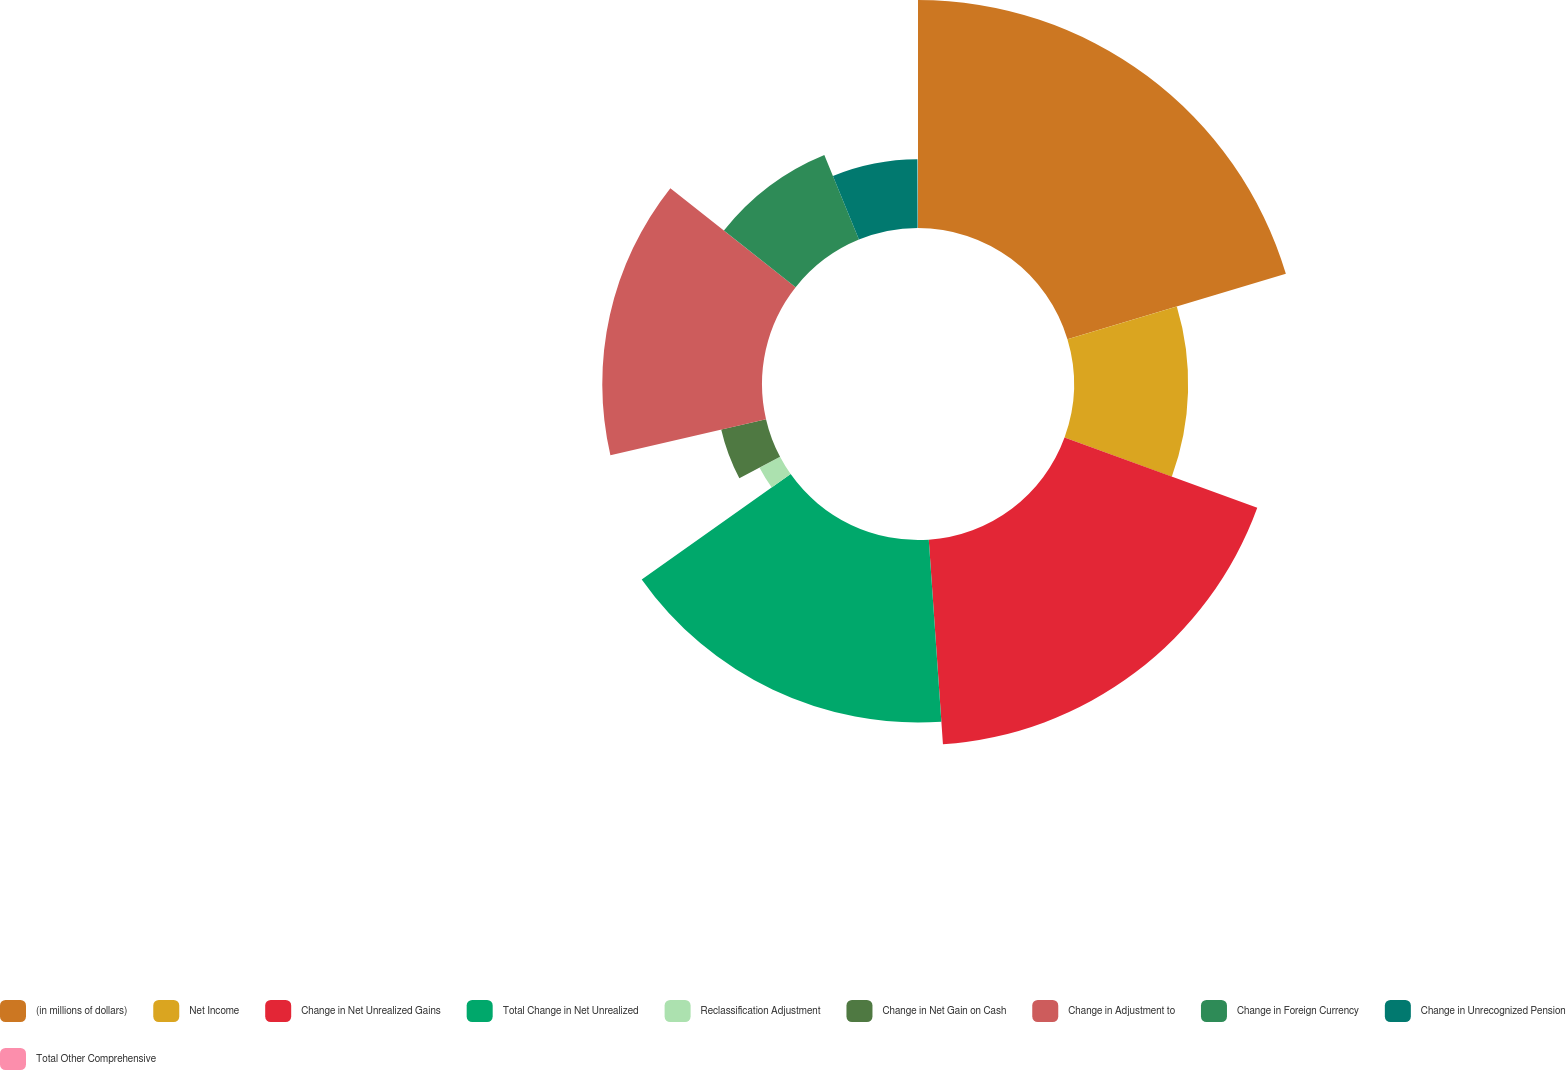Convert chart to OTSL. <chart><loc_0><loc_0><loc_500><loc_500><pie_chart><fcel>(in millions of dollars)<fcel>Net Income<fcel>Change in Net Unrealized Gains<fcel>Total Change in Net Unrealized<fcel>Reclassification Adjustment<fcel>Change in Net Gain on Cash<fcel>Change in Adjustment to<fcel>Change in Foreign Currency<fcel>Change in Unrecognized Pension<fcel>Total Other Comprehensive<nl><fcel>20.37%<fcel>10.2%<fcel>18.33%<fcel>16.3%<fcel>2.07%<fcel>4.11%<fcel>14.27%<fcel>8.17%<fcel>6.14%<fcel>0.04%<nl></chart> 